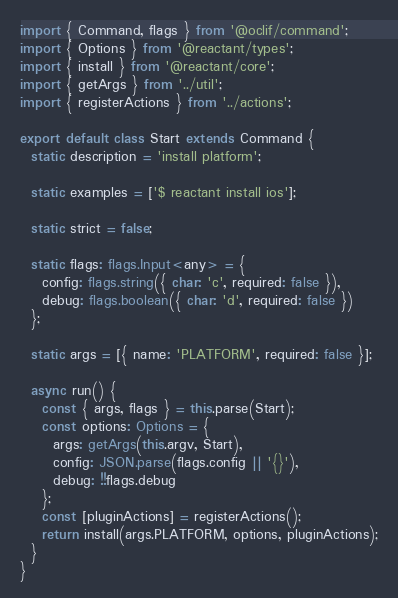Convert code to text. <code><loc_0><loc_0><loc_500><loc_500><_TypeScript_>import { Command, flags } from '@oclif/command';
import { Options } from '@reactant/types';
import { install } from '@reactant/core';
import { getArgs } from '../util';
import { registerActions } from '../actions';

export default class Start extends Command {
  static description = 'install platform';

  static examples = ['$ reactant install ios'];

  static strict = false;

  static flags: flags.Input<any> = {
    config: flags.string({ char: 'c', required: false }),
    debug: flags.boolean({ char: 'd', required: false })
  };

  static args = [{ name: 'PLATFORM', required: false }];

  async run() {
    const { args, flags } = this.parse(Start);
    const options: Options = {
      args: getArgs(this.argv, Start),
      config: JSON.parse(flags.config || '{}'),
      debug: !!flags.debug
    };
    const [pluginActions] = registerActions();
    return install(args.PLATFORM, options, pluginActions);
  }
}
</code> 